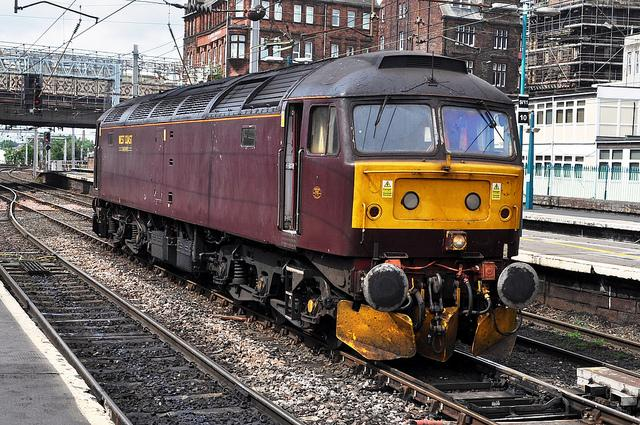What type of area is in the background? city 